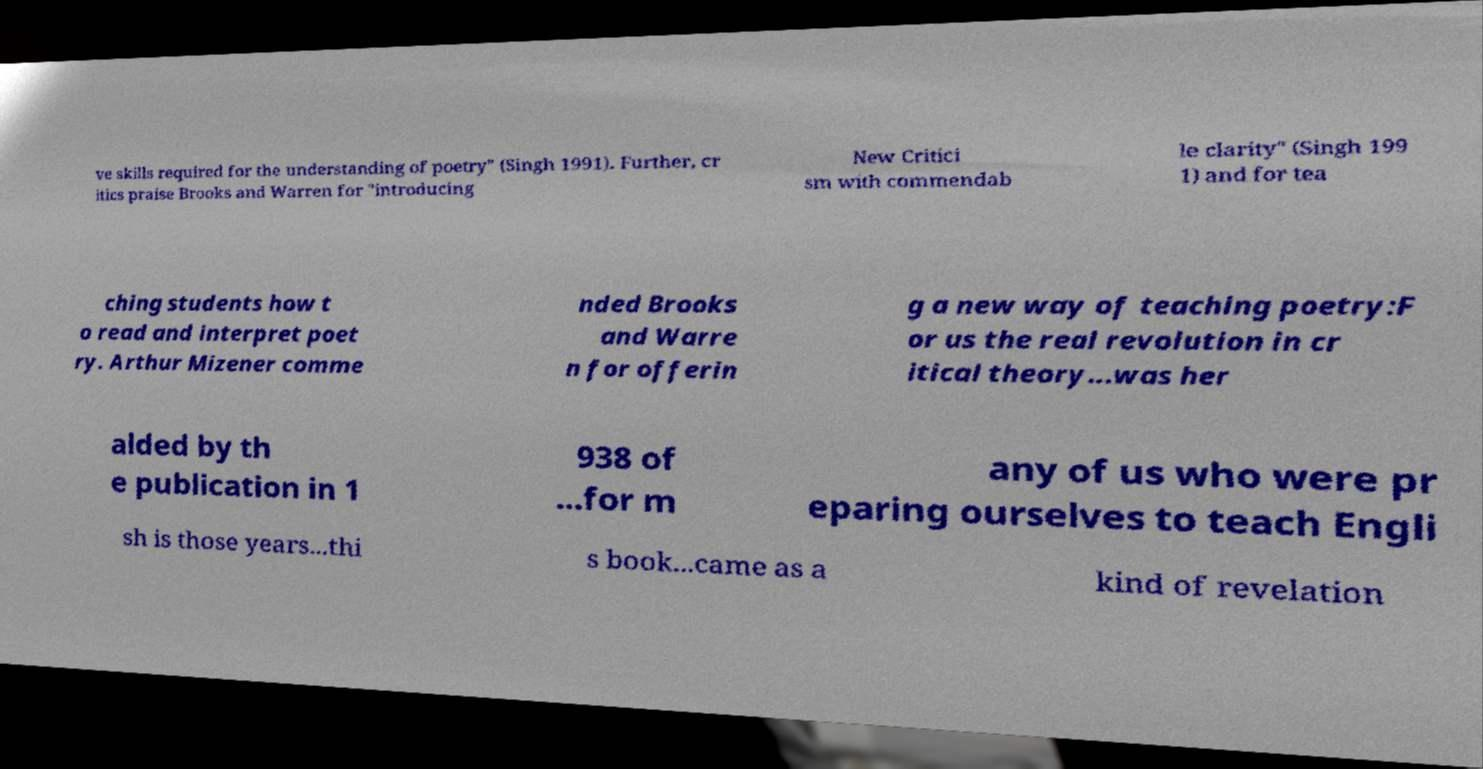Could you extract and type out the text from this image? ve skills required for the understanding of poetry" (Singh 1991). Further, cr itics praise Brooks and Warren for "introducing New Critici sm with commendab le clarity" (Singh 199 1) and for tea ching students how t o read and interpret poet ry. Arthur Mizener comme nded Brooks and Warre n for offerin g a new way of teaching poetry:F or us the real revolution in cr itical theory...was her alded by th e publication in 1 938 of ...for m any of us who were pr eparing ourselves to teach Engli sh is those years...thi s book...came as a kind of revelation 